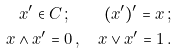Convert formula to latex. <formula><loc_0><loc_0><loc_500><loc_500>x ^ { \prime } \in C \, ; \quad ( x ^ { \prime } ) ^ { \prime } = x \, ; \\ x \wedge x ^ { \prime } = 0 \, , \quad x \vee x ^ { \prime } = 1 \, .</formula> 